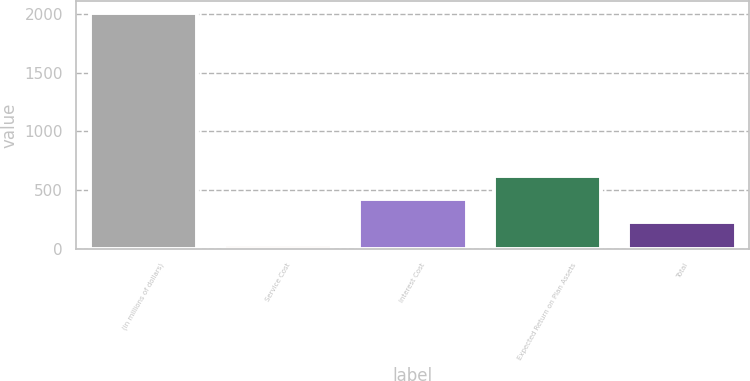<chart> <loc_0><loc_0><loc_500><loc_500><bar_chart><fcel>(in millions of dollars)<fcel>Service Cost<fcel>Interest Cost<fcel>Expected Return on Plan Assets<fcel>Total<nl><fcel>2007<fcel>31.9<fcel>426.92<fcel>624.43<fcel>229.41<nl></chart> 